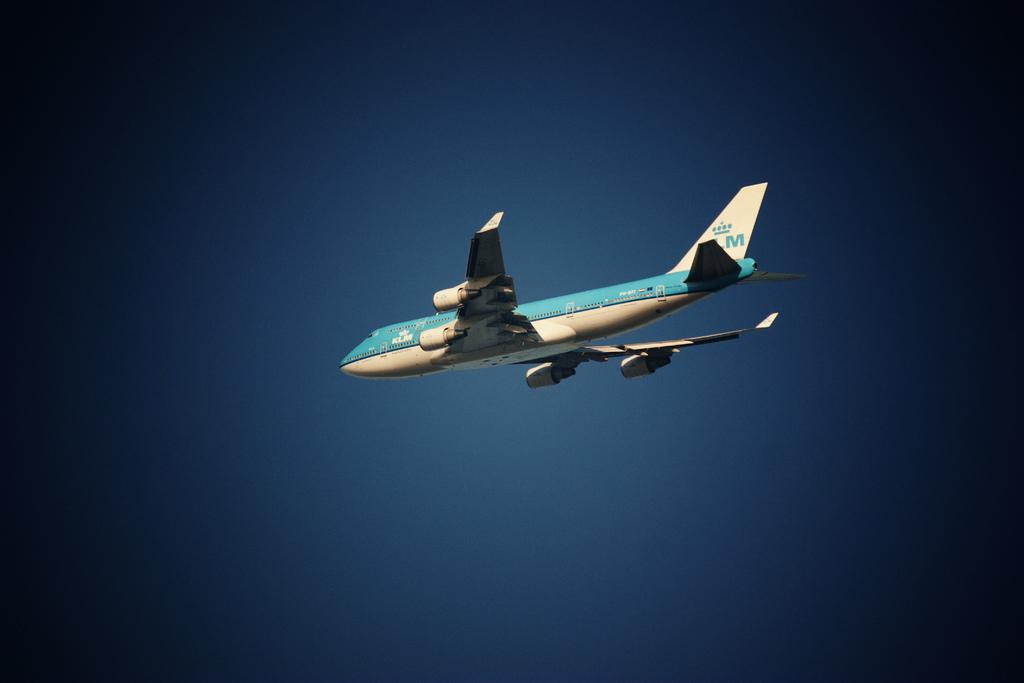What is the main subject of the image? The main subject of the image is an airplane. Can you describe the position of the airplane in the image? The airplane is in the air in the image. What is visible in the background of the image? There is sky visible in the background of the image. What type of paste can be seen being applied to the wings of the airplane in the image? There is no paste visible on the airplane in the image. What is the chance of encountering a fictional creature flying alongside the airplane in the image? There is no fictional creature present in the image. 